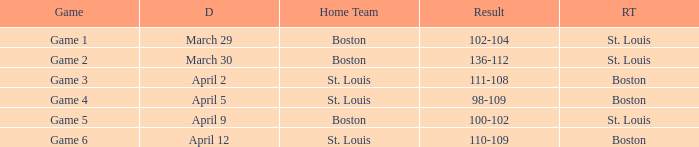What is the Result of the Game on April 9? 100-102. 